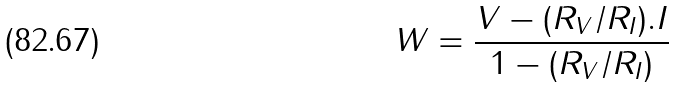<formula> <loc_0><loc_0><loc_500><loc_500>W = \frac { V - ( R _ { V } / R _ { I } ) . I } { 1 - ( R _ { V } / R _ { I } ) }</formula> 